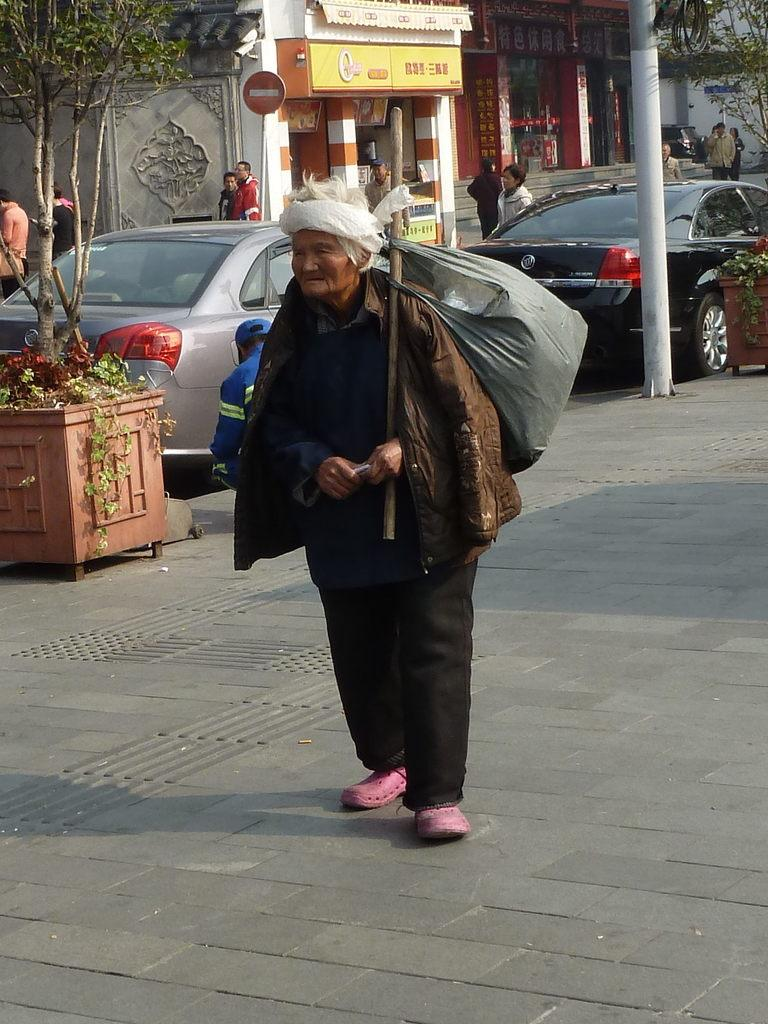What is the person in the image doing? The person is standing in the image. What is the person holding in the image? The person is holding a bag. What type of vehicles can be seen on the road in the image? Cars are visible on the road in the image. What natural element is present in the image? There is a tree in the image. What type of structure is visible in the image? There is a building in the image. Is there a boy in the image who is representing his school in a debate competition? There is no information about a debate competition or a boy representing his school in the image. 